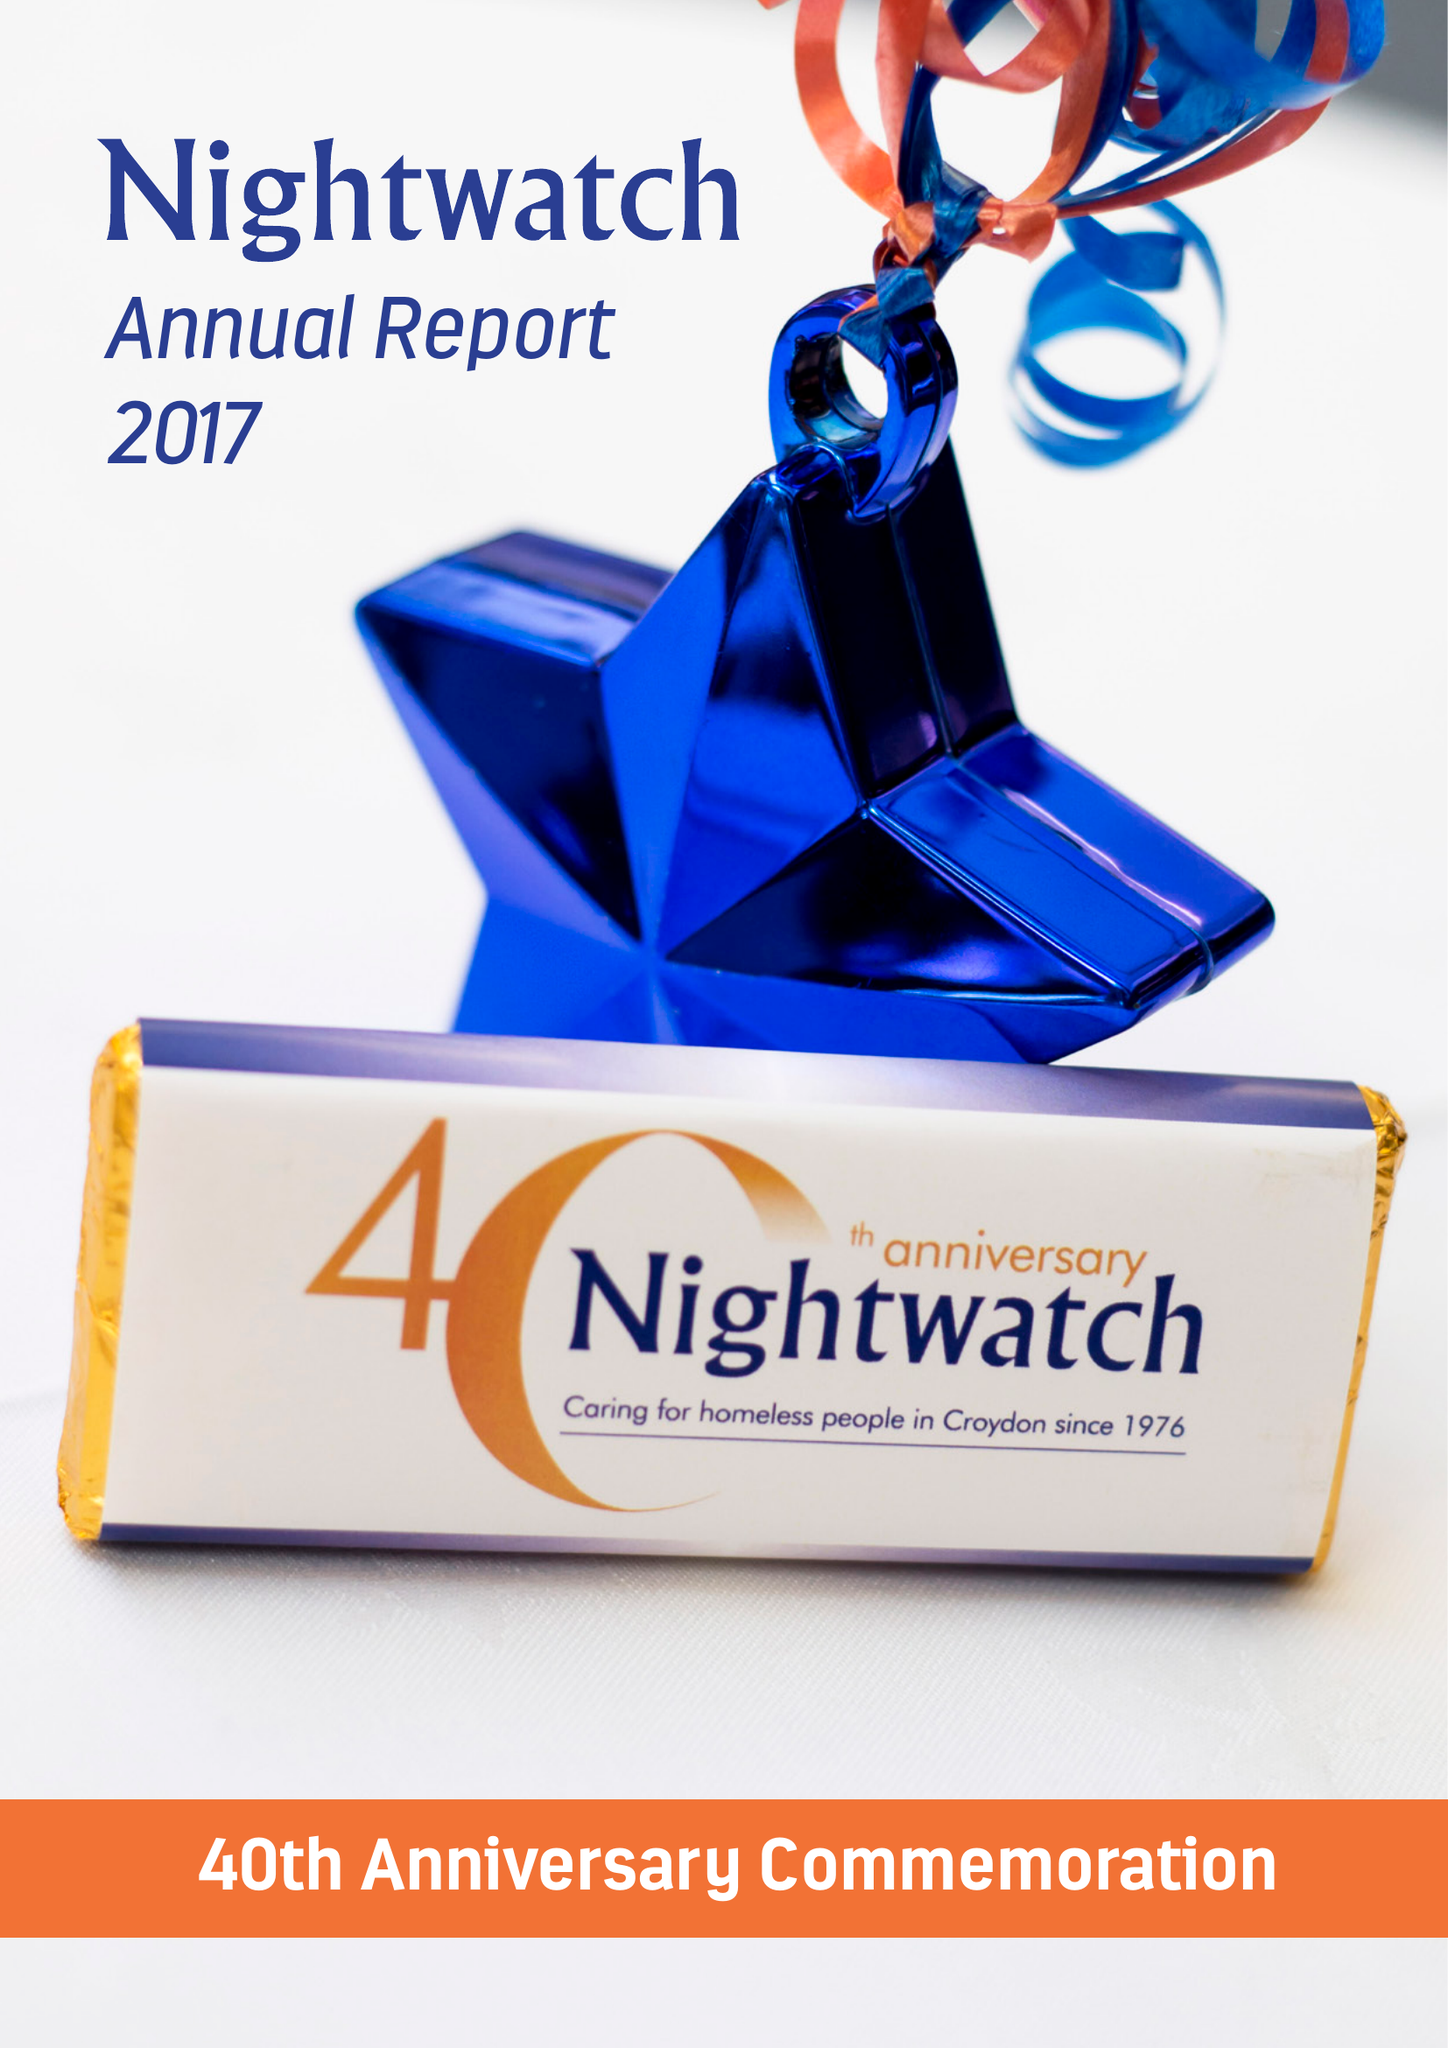What is the value for the address__postcode?
Answer the question using a single word or phrase. SE23 3ZH 